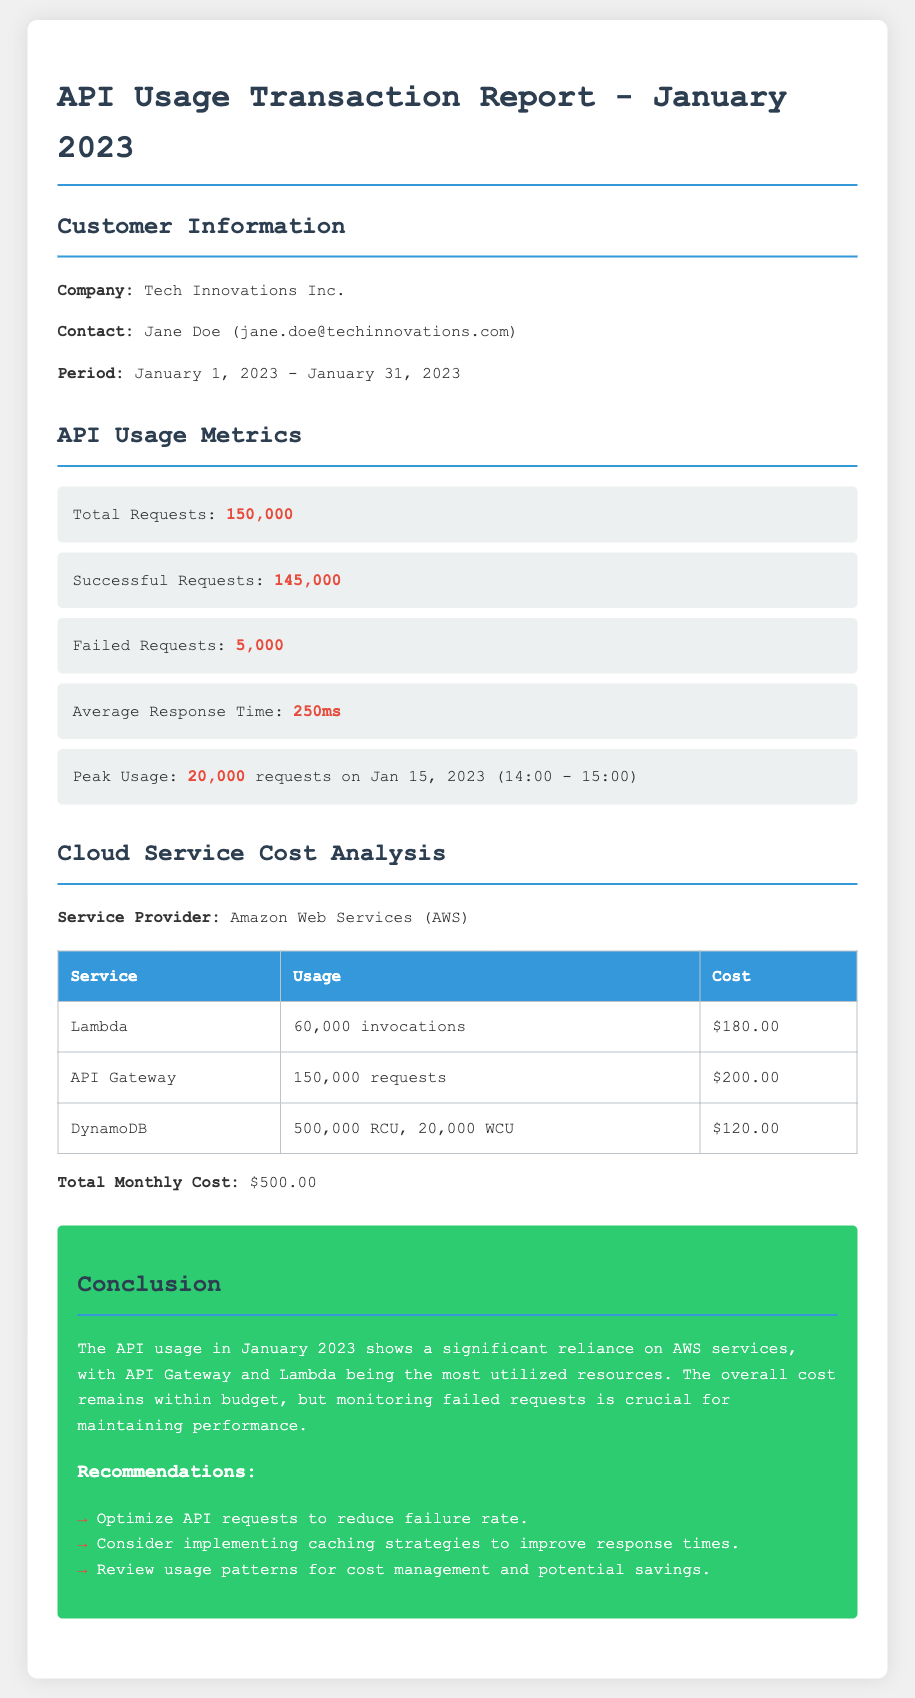What is the company name? The company name is listed in the customer information section.
Answer: Tech Innovations Inc What is the total number of requests? The total number of requests is provided in the API usage metrics section.
Answer: 150,000 What is the cost for Lambda service? The cost for the Lambda service is detailed in the cloud service cost analysis table.
Answer: $180.00 What percentage of successful requests? To find the percentage, you calculate successful requests divided by total requests. Successful requests are 145,000 out of 150,000.
Answer: 96.67% What was the peak usage date and time? The peak usage details are specified in the API usage metrics section.
Answer: Jan 15, 2023 (14:00 - 15:00) What is the total monthly cost for cloud services? The total monthly cost is mentioned at the end of the cloud service cost analysis section.
Answer: $500.00 How many failed requests were there? The number of failed requests is mentioned in the API usage metrics.
Answer: 5,000 Which service had the highest cost? The highest cost service is identified in the cloud service cost analysis table.
Answer: API Gateway What is the average response time? Average response time is specified in the API usage metrics.
Answer: 250ms 